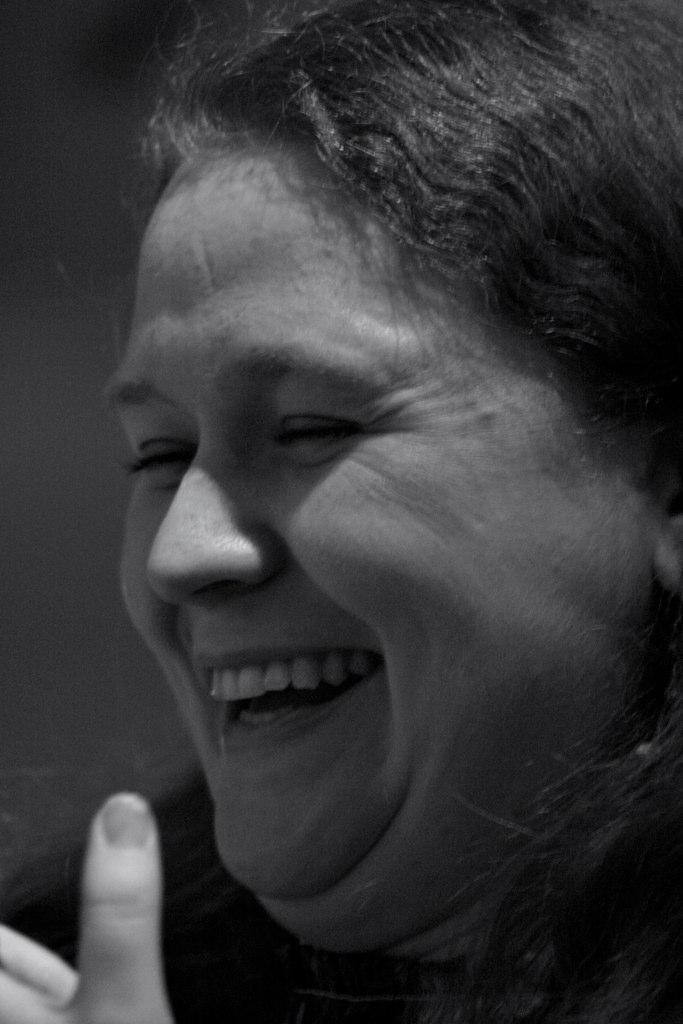What is present in the image? There is a person in the image. How is the person's facial expression? The person has a smiling face. What type of yoke is being used by the person in the image? There is no yoke present in the image; it only features a person with a smiling face. 